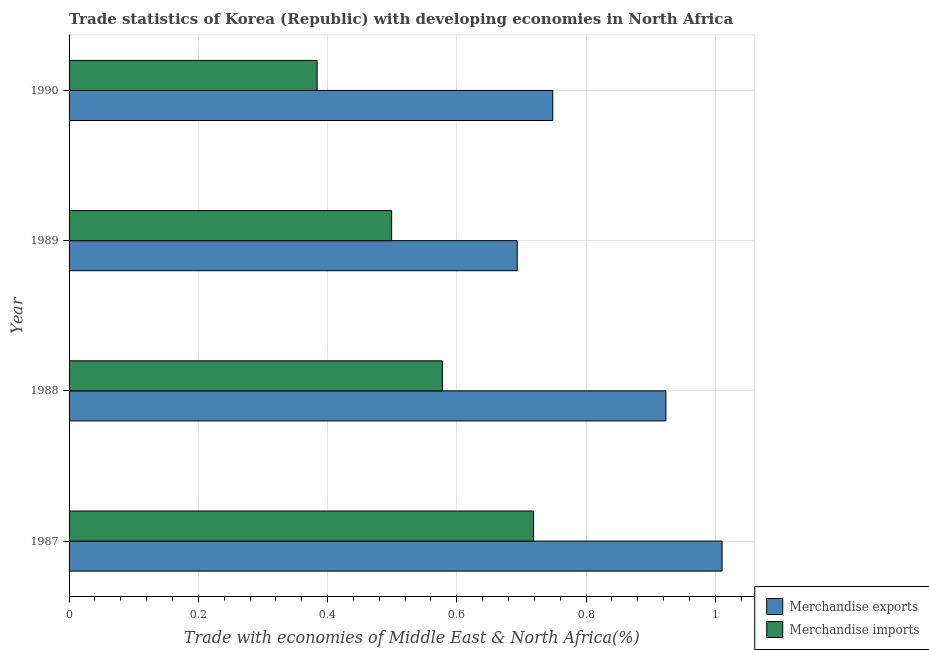How many different coloured bars are there?
Offer a very short reply. 2. How many groups of bars are there?
Give a very brief answer. 4. Are the number of bars on each tick of the Y-axis equal?
Your answer should be very brief. Yes. How many bars are there on the 2nd tick from the bottom?
Keep it short and to the point. 2. In how many cases, is the number of bars for a given year not equal to the number of legend labels?
Your response must be concise. 0. What is the merchandise exports in 1988?
Provide a succinct answer. 0.92. Across all years, what is the maximum merchandise imports?
Keep it short and to the point. 0.72. Across all years, what is the minimum merchandise exports?
Provide a short and direct response. 0.69. In which year was the merchandise exports maximum?
Provide a short and direct response. 1987. What is the total merchandise imports in the graph?
Your answer should be very brief. 2.18. What is the difference between the merchandise imports in 1989 and that in 1990?
Your answer should be compact. 0.12. What is the difference between the merchandise imports in 1990 and the merchandise exports in 1987?
Make the answer very short. -0.63. What is the average merchandise exports per year?
Ensure brevity in your answer.  0.84. In the year 1987, what is the difference between the merchandise exports and merchandise imports?
Offer a terse response. 0.29. What is the ratio of the merchandise imports in 1989 to that in 1990?
Your response must be concise. 1.3. Is the merchandise exports in 1987 less than that in 1989?
Provide a short and direct response. No. Is the difference between the merchandise imports in 1988 and 1989 greater than the difference between the merchandise exports in 1988 and 1989?
Your answer should be compact. No. What is the difference between the highest and the second highest merchandise exports?
Give a very brief answer. 0.09. What is the difference between the highest and the lowest merchandise exports?
Provide a succinct answer. 0.32. Is the sum of the merchandise exports in 1988 and 1990 greater than the maximum merchandise imports across all years?
Provide a short and direct response. Yes. What does the 2nd bar from the top in 1988 represents?
Give a very brief answer. Merchandise exports. How many bars are there?
Make the answer very short. 8. Are the values on the major ticks of X-axis written in scientific E-notation?
Provide a succinct answer. No. Does the graph contain any zero values?
Offer a terse response. No. Does the graph contain grids?
Make the answer very short. Yes. Where does the legend appear in the graph?
Make the answer very short. Bottom right. How many legend labels are there?
Ensure brevity in your answer.  2. What is the title of the graph?
Offer a terse response. Trade statistics of Korea (Republic) with developing economies in North Africa. What is the label or title of the X-axis?
Provide a succinct answer. Trade with economies of Middle East & North Africa(%). What is the label or title of the Y-axis?
Provide a succinct answer. Year. What is the Trade with economies of Middle East & North Africa(%) in Merchandise exports in 1987?
Your response must be concise. 1.01. What is the Trade with economies of Middle East & North Africa(%) of Merchandise imports in 1987?
Keep it short and to the point. 0.72. What is the Trade with economies of Middle East & North Africa(%) of Merchandise exports in 1988?
Ensure brevity in your answer.  0.92. What is the Trade with economies of Middle East & North Africa(%) in Merchandise imports in 1988?
Your answer should be compact. 0.58. What is the Trade with economies of Middle East & North Africa(%) in Merchandise exports in 1989?
Provide a short and direct response. 0.69. What is the Trade with economies of Middle East & North Africa(%) in Merchandise imports in 1989?
Ensure brevity in your answer.  0.5. What is the Trade with economies of Middle East & North Africa(%) of Merchandise exports in 1990?
Ensure brevity in your answer.  0.75. What is the Trade with economies of Middle East & North Africa(%) in Merchandise imports in 1990?
Ensure brevity in your answer.  0.38. Across all years, what is the maximum Trade with economies of Middle East & North Africa(%) of Merchandise exports?
Your response must be concise. 1.01. Across all years, what is the maximum Trade with economies of Middle East & North Africa(%) in Merchandise imports?
Your response must be concise. 0.72. Across all years, what is the minimum Trade with economies of Middle East & North Africa(%) of Merchandise exports?
Give a very brief answer. 0.69. Across all years, what is the minimum Trade with economies of Middle East & North Africa(%) in Merchandise imports?
Make the answer very short. 0.38. What is the total Trade with economies of Middle East & North Africa(%) of Merchandise exports in the graph?
Your answer should be very brief. 3.38. What is the total Trade with economies of Middle East & North Africa(%) in Merchandise imports in the graph?
Make the answer very short. 2.18. What is the difference between the Trade with economies of Middle East & North Africa(%) in Merchandise exports in 1987 and that in 1988?
Give a very brief answer. 0.09. What is the difference between the Trade with economies of Middle East & North Africa(%) of Merchandise imports in 1987 and that in 1988?
Give a very brief answer. 0.14. What is the difference between the Trade with economies of Middle East & North Africa(%) of Merchandise exports in 1987 and that in 1989?
Provide a short and direct response. 0.32. What is the difference between the Trade with economies of Middle East & North Africa(%) of Merchandise imports in 1987 and that in 1989?
Ensure brevity in your answer.  0.22. What is the difference between the Trade with economies of Middle East & North Africa(%) of Merchandise exports in 1987 and that in 1990?
Your answer should be compact. 0.26. What is the difference between the Trade with economies of Middle East & North Africa(%) of Merchandise imports in 1987 and that in 1990?
Give a very brief answer. 0.34. What is the difference between the Trade with economies of Middle East & North Africa(%) of Merchandise exports in 1988 and that in 1989?
Offer a terse response. 0.23. What is the difference between the Trade with economies of Middle East & North Africa(%) in Merchandise imports in 1988 and that in 1989?
Offer a terse response. 0.08. What is the difference between the Trade with economies of Middle East & North Africa(%) in Merchandise exports in 1988 and that in 1990?
Make the answer very short. 0.17. What is the difference between the Trade with economies of Middle East & North Africa(%) of Merchandise imports in 1988 and that in 1990?
Give a very brief answer. 0.19. What is the difference between the Trade with economies of Middle East & North Africa(%) in Merchandise exports in 1989 and that in 1990?
Offer a terse response. -0.06. What is the difference between the Trade with economies of Middle East & North Africa(%) of Merchandise imports in 1989 and that in 1990?
Provide a succinct answer. 0.12. What is the difference between the Trade with economies of Middle East & North Africa(%) in Merchandise exports in 1987 and the Trade with economies of Middle East & North Africa(%) in Merchandise imports in 1988?
Your response must be concise. 0.43. What is the difference between the Trade with economies of Middle East & North Africa(%) in Merchandise exports in 1987 and the Trade with economies of Middle East & North Africa(%) in Merchandise imports in 1989?
Keep it short and to the point. 0.51. What is the difference between the Trade with economies of Middle East & North Africa(%) of Merchandise exports in 1987 and the Trade with economies of Middle East & North Africa(%) of Merchandise imports in 1990?
Make the answer very short. 0.63. What is the difference between the Trade with economies of Middle East & North Africa(%) in Merchandise exports in 1988 and the Trade with economies of Middle East & North Africa(%) in Merchandise imports in 1989?
Your answer should be compact. 0.42. What is the difference between the Trade with economies of Middle East & North Africa(%) in Merchandise exports in 1988 and the Trade with economies of Middle East & North Africa(%) in Merchandise imports in 1990?
Provide a succinct answer. 0.54. What is the difference between the Trade with economies of Middle East & North Africa(%) in Merchandise exports in 1989 and the Trade with economies of Middle East & North Africa(%) in Merchandise imports in 1990?
Your answer should be compact. 0.31. What is the average Trade with economies of Middle East & North Africa(%) in Merchandise exports per year?
Keep it short and to the point. 0.84. What is the average Trade with economies of Middle East & North Africa(%) of Merchandise imports per year?
Offer a very short reply. 0.54. In the year 1987, what is the difference between the Trade with economies of Middle East & North Africa(%) of Merchandise exports and Trade with economies of Middle East & North Africa(%) of Merchandise imports?
Provide a short and direct response. 0.29. In the year 1988, what is the difference between the Trade with economies of Middle East & North Africa(%) in Merchandise exports and Trade with economies of Middle East & North Africa(%) in Merchandise imports?
Keep it short and to the point. 0.35. In the year 1989, what is the difference between the Trade with economies of Middle East & North Africa(%) in Merchandise exports and Trade with economies of Middle East & North Africa(%) in Merchandise imports?
Ensure brevity in your answer.  0.19. In the year 1990, what is the difference between the Trade with economies of Middle East & North Africa(%) of Merchandise exports and Trade with economies of Middle East & North Africa(%) of Merchandise imports?
Provide a succinct answer. 0.36. What is the ratio of the Trade with economies of Middle East & North Africa(%) of Merchandise exports in 1987 to that in 1988?
Your response must be concise. 1.09. What is the ratio of the Trade with economies of Middle East & North Africa(%) in Merchandise imports in 1987 to that in 1988?
Your answer should be compact. 1.24. What is the ratio of the Trade with economies of Middle East & North Africa(%) in Merchandise exports in 1987 to that in 1989?
Give a very brief answer. 1.46. What is the ratio of the Trade with economies of Middle East & North Africa(%) in Merchandise imports in 1987 to that in 1989?
Your answer should be very brief. 1.44. What is the ratio of the Trade with economies of Middle East & North Africa(%) in Merchandise exports in 1987 to that in 1990?
Keep it short and to the point. 1.35. What is the ratio of the Trade with economies of Middle East & North Africa(%) of Merchandise imports in 1987 to that in 1990?
Your answer should be compact. 1.87. What is the ratio of the Trade with economies of Middle East & North Africa(%) in Merchandise exports in 1988 to that in 1989?
Offer a very short reply. 1.33. What is the ratio of the Trade with economies of Middle East & North Africa(%) in Merchandise imports in 1988 to that in 1989?
Offer a very short reply. 1.16. What is the ratio of the Trade with economies of Middle East & North Africa(%) of Merchandise exports in 1988 to that in 1990?
Offer a very short reply. 1.23. What is the ratio of the Trade with economies of Middle East & North Africa(%) in Merchandise imports in 1988 to that in 1990?
Your response must be concise. 1.5. What is the ratio of the Trade with economies of Middle East & North Africa(%) in Merchandise exports in 1989 to that in 1990?
Give a very brief answer. 0.93. What is the ratio of the Trade with economies of Middle East & North Africa(%) in Merchandise imports in 1989 to that in 1990?
Your answer should be very brief. 1.3. What is the difference between the highest and the second highest Trade with economies of Middle East & North Africa(%) in Merchandise exports?
Your answer should be compact. 0.09. What is the difference between the highest and the second highest Trade with economies of Middle East & North Africa(%) of Merchandise imports?
Provide a short and direct response. 0.14. What is the difference between the highest and the lowest Trade with economies of Middle East & North Africa(%) of Merchandise exports?
Offer a very short reply. 0.32. What is the difference between the highest and the lowest Trade with economies of Middle East & North Africa(%) of Merchandise imports?
Keep it short and to the point. 0.34. 